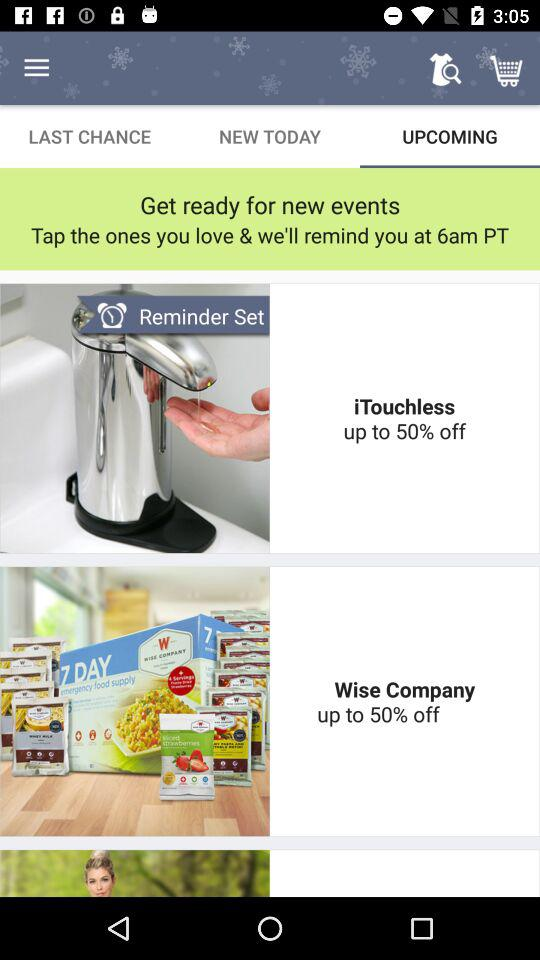How many items are on sale?
Answer the question using a single word or phrase. 2 